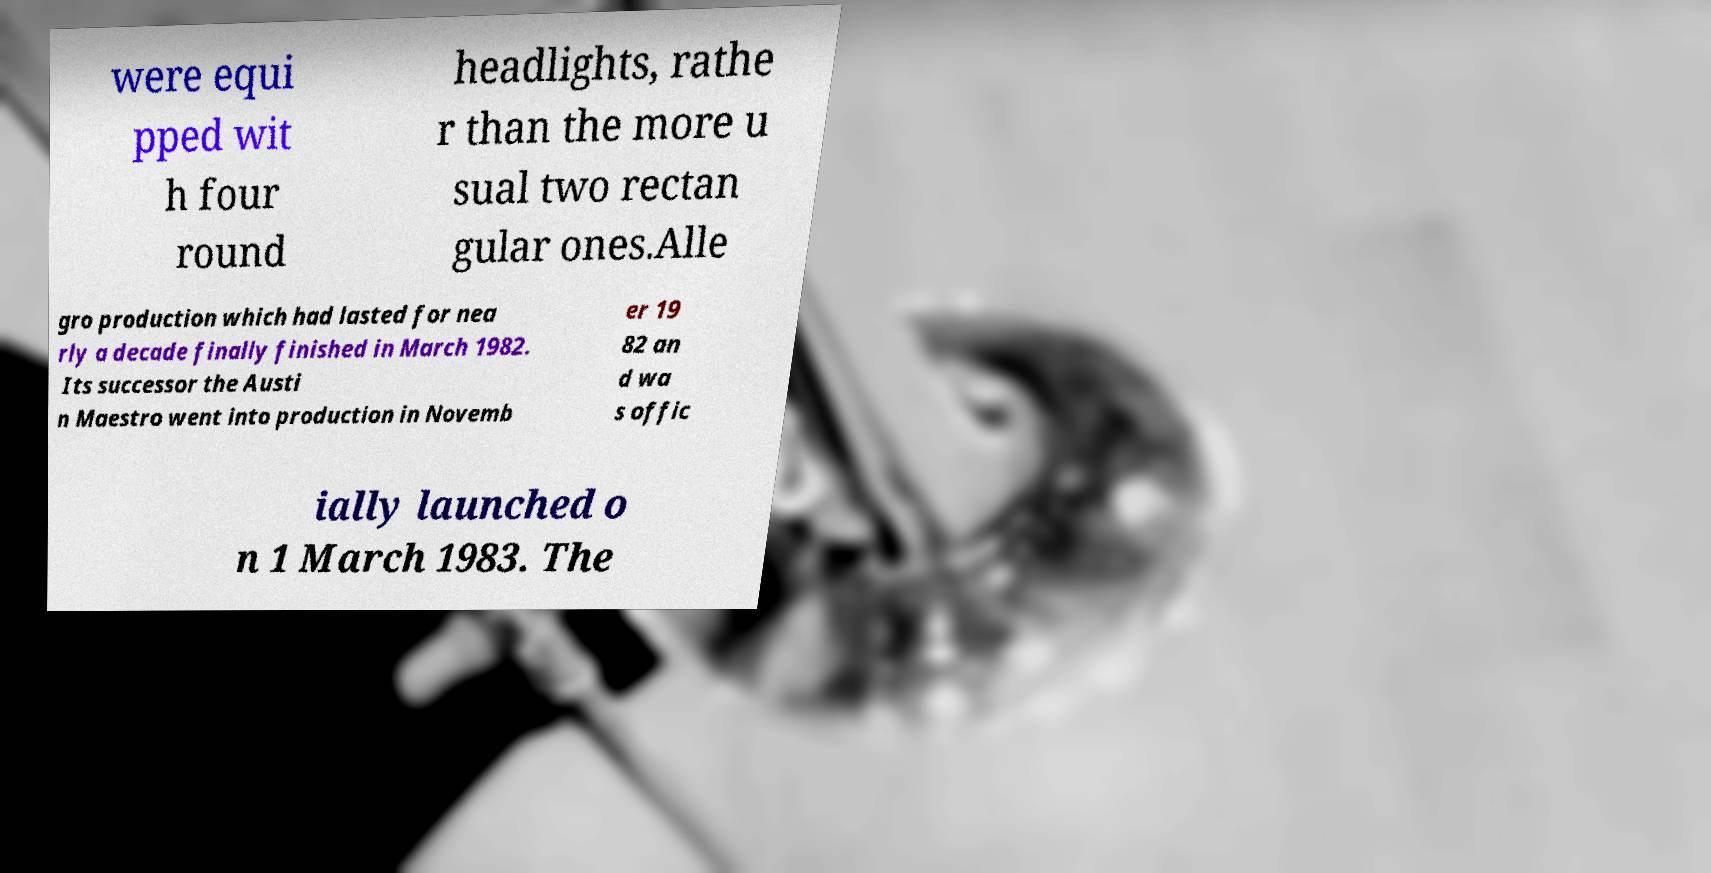I need the written content from this picture converted into text. Can you do that? were equi pped wit h four round headlights, rathe r than the more u sual two rectan gular ones.Alle gro production which had lasted for nea rly a decade finally finished in March 1982. Its successor the Austi n Maestro went into production in Novemb er 19 82 an d wa s offic ially launched o n 1 March 1983. The 